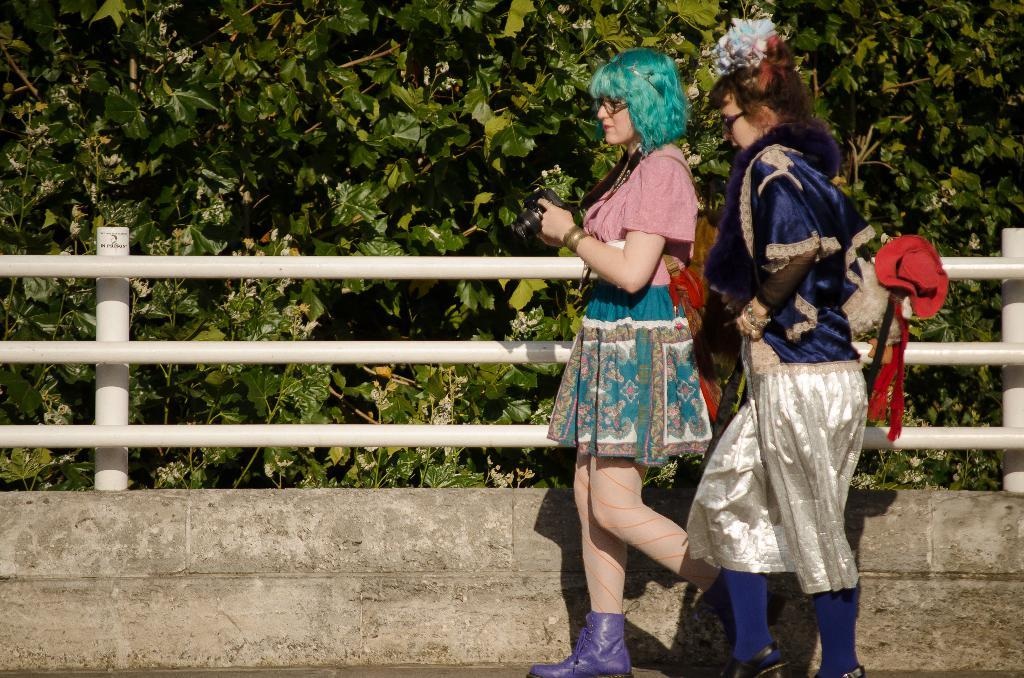How many people are in the image? There are two women in the image. What are the women doing in the image? The women are walking on the road. What can be seen in the front of the image? There is a railing and a wall in the front of the image. What is the color of the railing? The railing is white in color. What is visible in the background of the image? There are trees in the background of the image. What type of crack can be seen on the wall in the image? There is no crack visible on the wall in the image. Can you tell me how many snails are crawling on the railing in the image? There are no snails present in the image. 